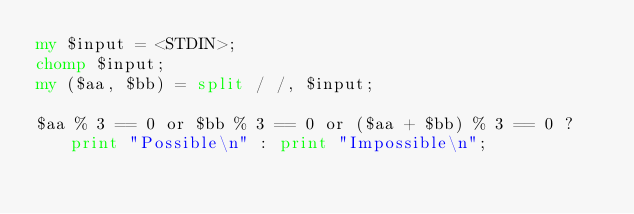<code> <loc_0><loc_0><loc_500><loc_500><_Perl_>my $input = <STDIN>;
chomp $input;
my ($aa, $bb) = split / /, $input;

$aa % 3 == 0 or $bb % 3 == 0 or ($aa + $bb) % 3 == 0 ? print "Possible\n" : print "Impossible\n";</code> 